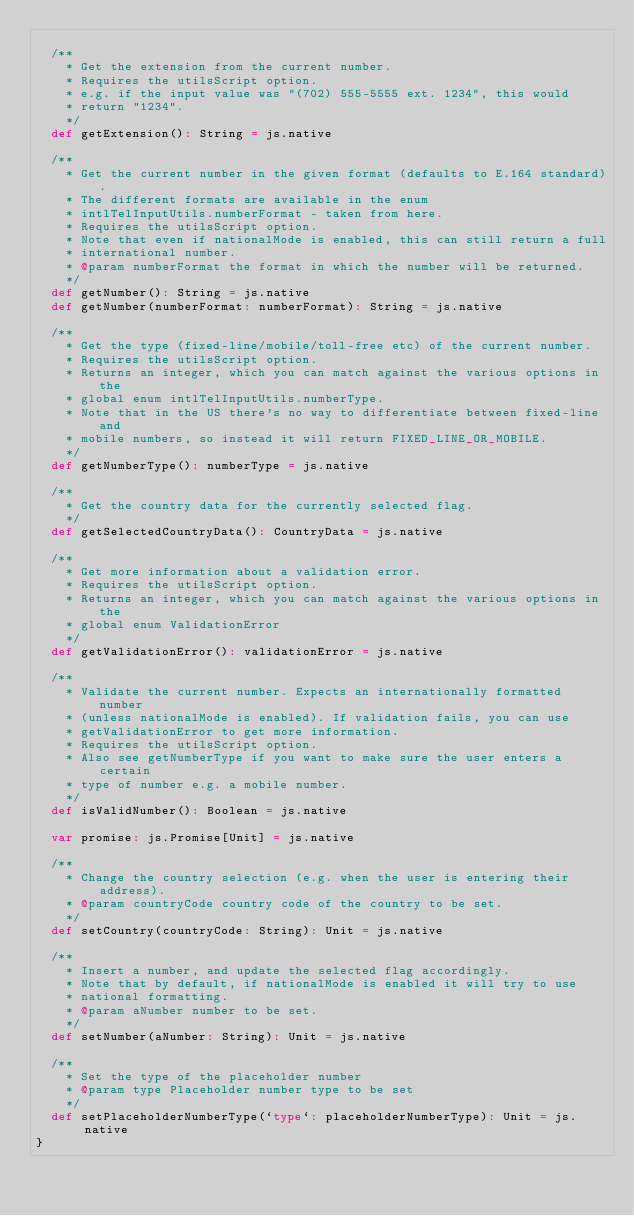<code> <loc_0><loc_0><loc_500><loc_500><_Scala_>  
  /**
    * Get the extension from the current number.
    * Requires the utilsScript option.
    * e.g. if the input value was "(702) 555-5555 ext. 1234", this would
    * return "1234".
    */
  def getExtension(): String = js.native
  
  /**
    * Get the current number in the given format (defaults to E.164 standard).
    * The different formats are available in the enum
    * intlTelInputUtils.numberFormat - taken from here.
    * Requires the utilsScript option.
    * Note that even if nationalMode is enabled, this can still return a full
    * international number.
    * @param numberFormat the format in which the number will be returned.
    */
  def getNumber(): String = js.native
  def getNumber(numberFormat: numberFormat): String = js.native
  
  /**
    * Get the type (fixed-line/mobile/toll-free etc) of the current number.
    * Requires the utilsScript option.
    * Returns an integer, which you can match against the various options in the
    * global enum intlTelInputUtils.numberType.
    * Note that in the US there's no way to differentiate between fixed-line and
    * mobile numbers, so instead it will return FIXED_LINE_OR_MOBILE.
    */
  def getNumberType(): numberType = js.native
  
  /**
    * Get the country data for the currently selected flag.
    */
  def getSelectedCountryData(): CountryData = js.native
  
  /**
    * Get more information about a validation error.
    * Requires the utilsScript option.
    * Returns an integer, which you can match against the various options in the
    * global enum ValidationError
    */
  def getValidationError(): validationError = js.native
  
  /**
    * Validate the current number. Expects an internationally formatted number
    * (unless nationalMode is enabled). If validation fails, you can use
    * getValidationError to get more information.
    * Requires the utilsScript option.
    * Also see getNumberType if you want to make sure the user enters a certain
    * type of number e.g. a mobile number.
    */
  def isValidNumber(): Boolean = js.native
  
  var promise: js.Promise[Unit] = js.native
  
  /**
    * Change the country selection (e.g. when the user is entering their address).
    * @param countryCode country code of the country to be set.
    */
  def setCountry(countryCode: String): Unit = js.native
  
  /**
    * Insert a number, and update the selected flag accordingly.
    * Note that by default, if nationalMode is enabled it will try to use
    * national formatting.
    * @param aNumber number to be set.
    */
  def setNumber(aNumber: String): Unit = js.native
  
  /**
    * Set the type of the placeholder number
    * @param type Placeholder number type to be set
    */
  def setPlaceholderNumberType(`type`: placeholderNumberType): Unit = js.native
}
</code> 